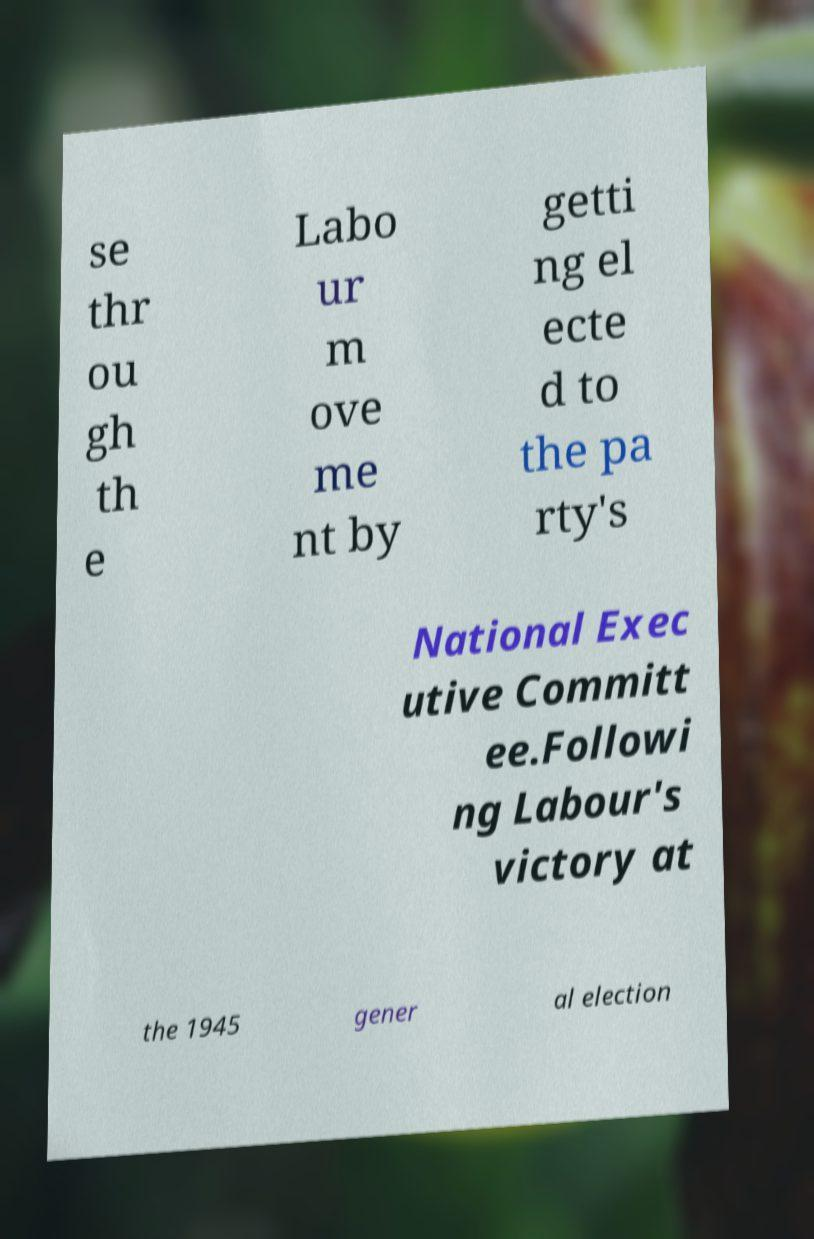For documentation purposes, I need the text within this image transcribed. Could you provide that? se thr ou gh th e Labo ur m ove me nt by getti ng el ecte d to the pa rty's National Exec utive Committ ee.Followi ng Labour's victory at the 1945 gener al election 